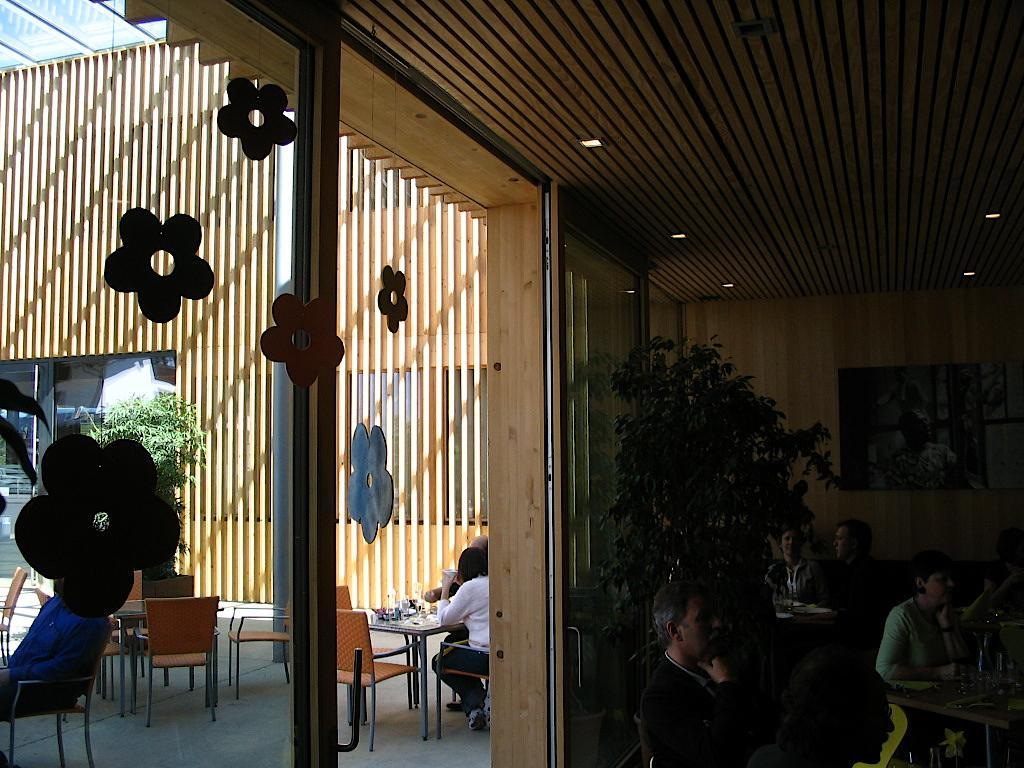How many people are in the image? There is a group of persons in the image. What are the persons doing in the image? The persons are sitting on chairs and tables. Where is the window located in the image? There is a window at the left side of the image. What type of degree is the pet holding in the image? There is no pet present in the image, and therefore no degree can be observed. 